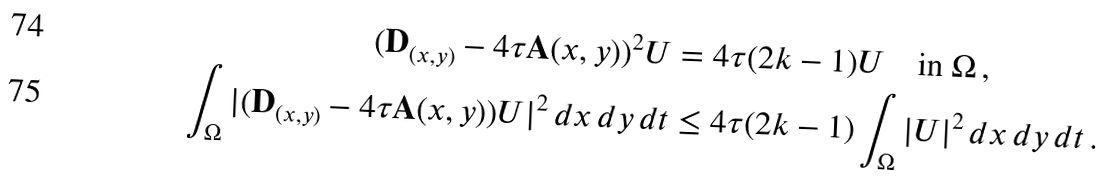<formula> <loc_0><loc_0><loc_500><loc_500>( \mathbf D _ { ( x , y ) } - 4 \tau \mathbf A ( x , y ) ) ^ { 2 } U & = 4 \tau ( 2 k - 1 ) U \quad \text {in} \ \Omega \, , \\ \int _ { \Omega } | ( \mathbf D _ { ( x , y ) } - 4 \tau \mathbf A ( x , y ) ) U | ^ { 2 } \, d x \, d y \, d t & \leq 4 \tau ( 2 k - 1 ) \int _ { \Omega } | U | ^ { 2 } \, d x \, d y \, d t \, .</formula> 